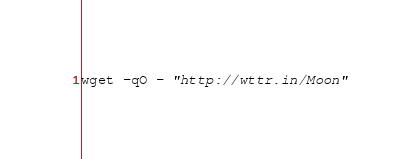Convert code to text. <code><loc_0><loc_0><loc_500><loc_500><_MoonScript_>wget -qO - "http://wttr.in/Moon"
</code> 